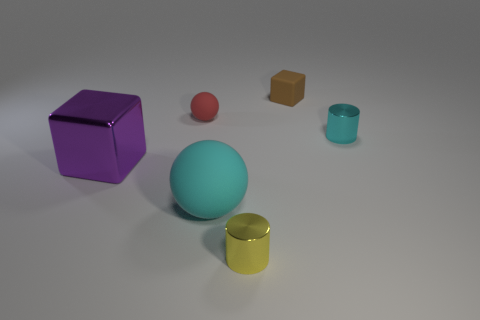There is a matte object in front of the cyan thing that is on the right side of the brown matte thing that is to the right of the yellow metallic cylinder; how big is it?
Keep it short and to the point. Large. Do the ball that is in front of the shiny block and the small cyan cylinder have the same material?
Provide a short and direct response. No. Are there the same number of yellow metal cylinders behind the tiny red ball and matte things right of the tiny brown matte thing?
Offer a very short reply. Yes. There is another tiny object that is the same shape as the small yellow thing; what is it made of?
Provide a succinct answer. Metal. Are there any cylinders that are right of the cube behind the big thing left of the big cyan matte thing?
Keep it short and to the point. Yes. There is a small shiny thing that is in front of the tiny cyan shiny cylinder; is it the same shape as the large thing behind the big cyan rubber object?
Offer a very short reply. No. Are there more small things to the left of the tiny yellow metallic thing than big red matte blocks?
Your response must be concise. Yes. What number of objects are red cubes or metal objects?
Offer a terse response. 3. The tiny matte cube has what color?
Give a very brief answer. Brown. How many other things are there of the same color as the big matte thing?
Make the answer very short. 1. 